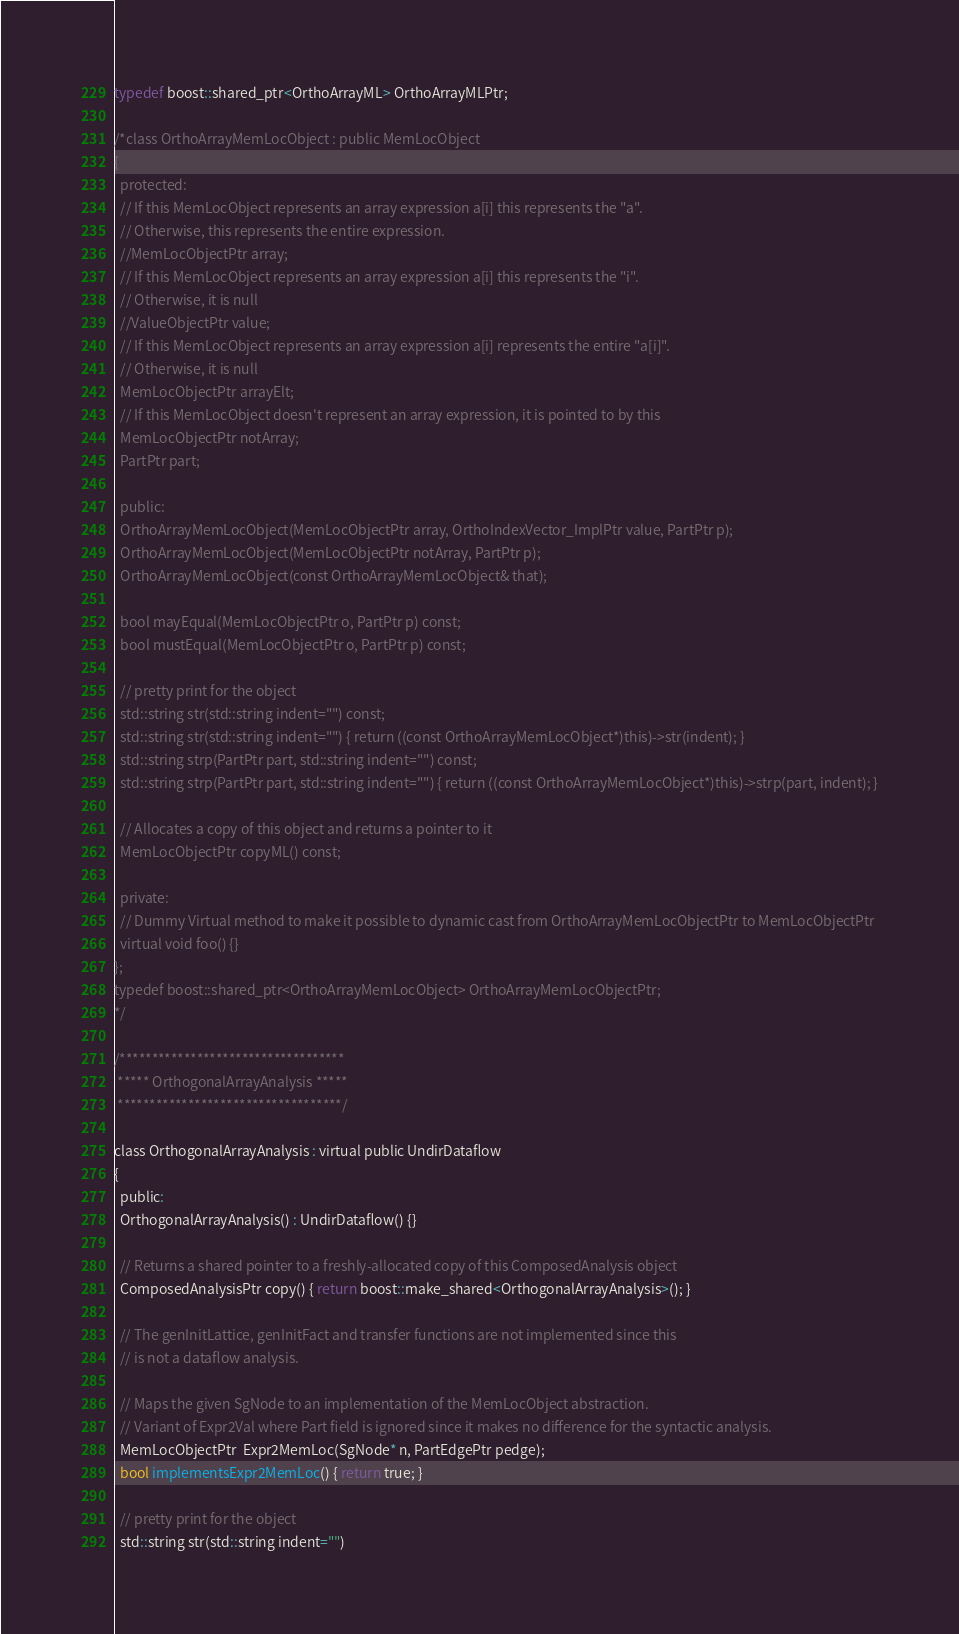Convert code to text. <code><loc_0><loc_0><loc_500><loc_500><_C_>typedef boost::shared_ptr<OrthoArrayML> OrthoArrayMLPtr;

/*class OrthoArrayMemLocObject : public MemLocObject
{
  protected:
  // If this MemLocObject represents an array expression a[i] this represents the "a".
  // Otherwise, this represents the entire expression.
  //MemLocObjectPtr array;
  // If this MemLocObject represents an array expression a[i] this represents the "i".
  // Otherwise, it is null
  //ValueObjectPtr value;
  // If this MemLocObject represents an array expression a[i] represents the entire "a[i]".
  // Otherwise, it is null
  MemLocObjectPtr arrayElt;
  // If this MemLocObject doesn't represent an array expression, it is pointed to by this
  MemLocObjectPtr notArray;
  PartPtr part;

  public:
  OrthoArrayMemLocObject(MemLocObjectPtr array, OrthoIndexVector_ImplPtr value, PartPtr p);
  OrthoArrayMemLocObject(MemLocObjectPtr notArray, PartPtr p);
  OrthoArrayMemLocObject(const OrthoArrayMemLocObject& that);

  bool mayEqual(MemLocObjectPtr o, PartPtr p) const;
  bool mustEqual(MemLocObjectPtr o, PartPtr p) const;
  
  // pretty print for the object
  std::string str(std::string indent="") const;
  std::string str(std::string indent="") { return ((const OrthoArrayMemLocObject*)this)->str(indent); }
  std::string strp(PartPtr part, std::string indent="") const;
  std::string strp(PartPtr part, std::string indent="") { return ((const OrthoArrayMemLocObject*)this)->strp(part, indent); }
  
  // Allocates a copy of this object and returns a pointer to it
  MemLocObjectPtr copyML() const;
  
  private:
  // Dummy Virtual method to make it possible to dynamic cast from OrthoArrayMemLocObjectPtr to MemLocObjectPtr
  virtual void foo() {}
};
typedef boost::shared_ptr<OrthoArrayMemLocObject> OrthoArrayMemLocObjectPtr;
*/

/***********************************
 ***** OrthogonalArrayAnalysis *****
 ***********************************/

class OrthogonalArrayAnalysis : virtual public UndirDataflow
{
  public:
  OrthogonalArrayAnalysis() : UndirDataflow() {}
    
  // Returns a shared pointer to a freshly-allocated copy of this ComposedAnalysis object
  ComposedAnalysisPtr copy() { return boost::make_shared<OrthogonalArrayAnalysis>(); }
    
  // The genInitLattice, genInitFact and transfer functions are not implemented since this 
  // is not a dataflow analysis.
   
  // Maps the given SgNode to an implementation of the MemLocObject abstraction.
  // Variant of Expr2Val where Part field is ignored since it makes no difference for the syntactic analysis.
  MemLocObjectPtr  Expr2MemLoc(SgNode* n, PartEdgePtr pedge);
  bool implementsExpr2MemLoc() { return true; }
  
  // pretty print for the object
  std::string str(std::string indent="")</code> 